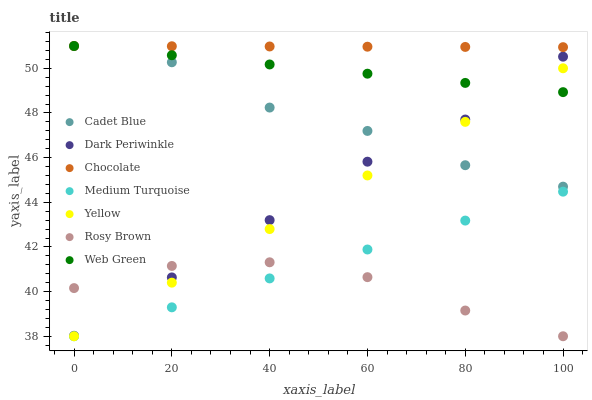Does Rosy Brown have the minimum area under the curve?
Answer yes or no. Yes. Does Chocolate have the maximum area under the curve?
Answer yes or no. Yes. Does Yellow have the minimum area under the curve?
Answer yes or no. No. Does Yellow have the maximum area under the curve?
Answer yes or no. No. Is Yellow the smoothest?
Answer yes or no. Yes. Is Cadet Blue the roughest?
Answer yes or no. Yes. Is Rosy Brown the smoothest?
Answer yes or no. No. Is Rosy Brown the roughest?
Answer yes or no. No. Does Rosy Brown have the lowest value?
Answer yes or no. Yes. Does Chocolate have the lowest value?
Answer yes or no. No. Does Web Green have the highest value?
Answer yes or no. Yes. Does Yellow have the highest value?
Answer yes or no. No. Is Rosy Brown less than Web Green?
Answer yes or no. Yes. Is Cadet Blue greater than Rosy Brown?
Answer yes or no. Yes. Does Yellow intersect Cadet Blue?
Answer yes or no. Yes. Is Yellow less than Cadet Blue?
Answer yes or no. No. Is Yellow greater than Cadet Blue?
Answer yes or no. No. Does Rosy Brown intersect Web Green?
Answer yes or no. No. 